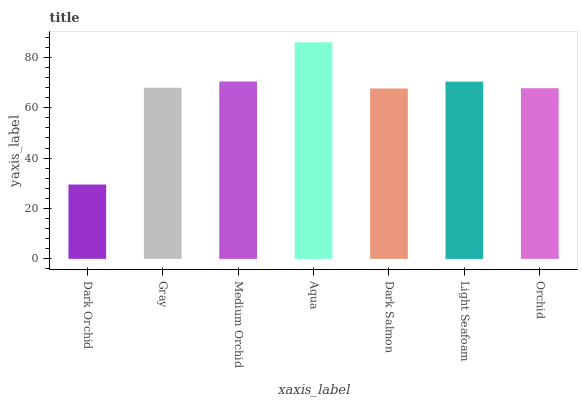Is Gray the minimum?
Answer yes or no. No. Is Gray the maximum?
Answer yes or no. No. Is Gray greater than Dark Orchid?
Answer yes or no. Yes. Is Dark Orchid less than Gray?
Answer yes or no. Yes. Is Dark Orchid greater than Gray?
Answer yes or no. No. Is Gray less than Dark Orchid?
Answer yes or no. No. Is Gray the high median?
Answer yes or no. Yes. Is Gray the low median?
Answer yes or no. Yes. Is Dark Salmon the high median?
Answer yes or no. No. Is Dark Orchid the low median?
Answer yes or no. No. 